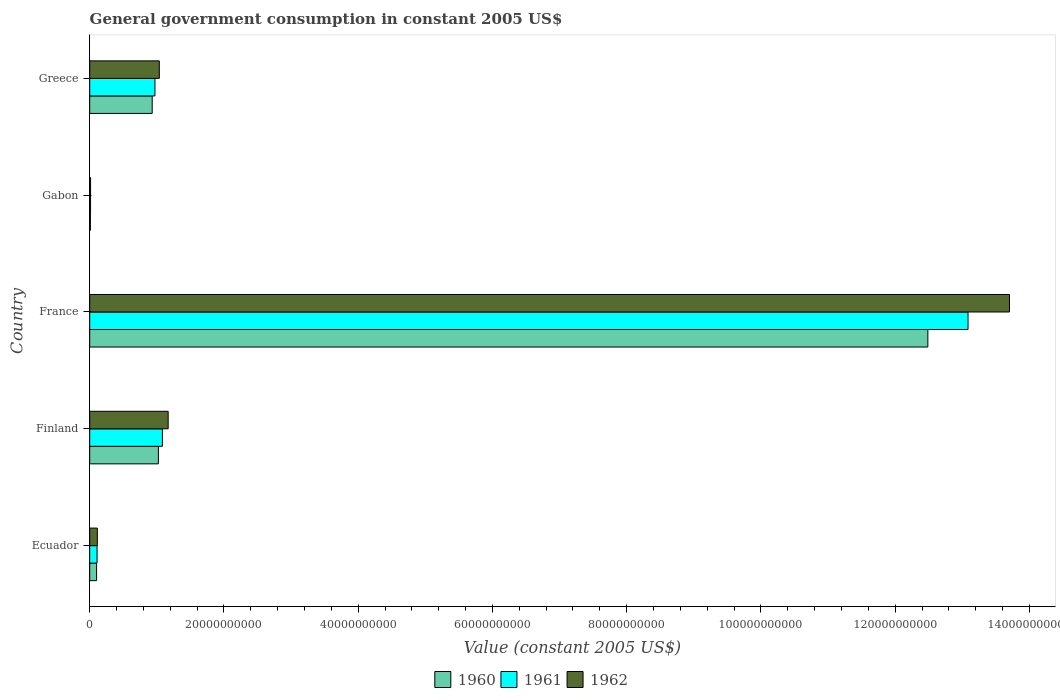How many different coloured bars are there?
Your answer should be very brief. 3. How many groups of bars are there?
Make the answer very short. 5. Are the number of bars per tick equal to the number of legend labels?
Provide a succinct answer. Yes. Are the number of bars on each tick of the Y-axis equal?
Your answer should be compact. Yes. How many bars are there on the 5th tick from the bottom?
Offer a very short reply. 3. What is the label of the 2nd group of bars from the top?
Provide a short and direct response. Gabon. In how many cases, is the number of bars for a given country not equal to the number of legend labels?
Make the answer very short. 0. What is the government conusmption in 1962 in Gabon?
Your answer should be compact. 1.31e+08. Across all countries, what is the maximum government conusmption in 1962?
Provide a short and direct response. 1.37e+11. Across all countries, what is the minimum government conusmption in 1960?
Provide a succinct answer. 1.04e+08. In which country was the government conusmption in 1961 minimum?
Provide a succinct answer. Gabon. What is the total government conusmption in 1961 in the graph?
Give a very brief answer. 1.53e+11. What is the difference between the government conusmption in 1960 in Ecuador and that in Greece?
Provide a short and direct response. -8.29e+09. What is the difference between the government conusmption in 1962 in Greece and the government conusmption in 1961 in France?
Make the answer very short. -1.20e+11. What is the average government conusmption in 1961 per country?
Provide a succinct answer. 3.05e+1. What is the difference between the government conusmption in 1961 and government conusmption in 1960 in Finland?
Provide a succinct answer. 5.98e+08. In how many countries, is the government conusmption in 1961 greater than 84000000000 US$?
Keep it short and to the point. 1. What is the ratio of the government conusmption in 1961 in Finland to that in France?
Provide a succinct answer. 0.08. What is the difference between the highest and the second highest government conusmption in 1960?
Ensure brevity in your answer.  1.15e+11. What is the difference between the highest and the lowest government conusmption in 1961?
Ensure brevity in your answer.  1.31e+11. In how many countries, is the government conusmption in 1960 greater than the average government conusmption in 1960 taken over all countries?
Ensure brevity in your answer.  1. Is the sum of the government conusmption in 1962 in Ecuador and Greece greater than the maximum government conusmption in 1960 across all countries?
Provide a succinct answer. No. Is it the case that in every country, the sum of the government conusmption in 1960 and government conusmption in 1961 is greater than the government conusmption in 1962?
Your answer should be very brief. Yes. How many bars are there?
Provide a short and direct response. 15. Are all the bars in the graph horizontal?
Make the answer very short. Yes. Does the graph contain any zero values?
Keep it short and to the point. No. Where does the legend appear in the graph?
Offer a very short reply. Bottom center. How are the legend labels stacked?
Provide a short and direct response. Horizontal. What is the title of the graph?
Provide a succinct answer. General government consumption in constant 2005 US$. Does "2004" appear as one of the legend labels in the graph?
Ensure brevity in your answer.  No. What is the label or title of the X-axis?
Provide a succinct answer. Value (constant 2005 US$). What is the label or title of the Y-axis?
Your answer should be compact. Country. What is the Value (constant 2005 US$) in 1960 in Ecuador?
Your answer should be compact. 1.03e+09. What is the Value (constant 2005 US$) of 1961 in Ecuador?
Offer a very short reply. 1.10e+09. What is the Value (constant 2005 US$) of 1962 in Ecuador?
Your answer should be very brief. 1.14e+09. What is the Value (constant 2005 US$) in 1960 in Finland?
Provide a short and direct response. 1.02e+1. What is the Value (constant 2005 US$) in 1961 in Finland?
Provide a short and direct response. 1.08e+1. What is the Value (constant 2005 US$) in 1962 in Finland?
Offer a terse response. 1.17e+1. What is the Value (constant 2005 US$) of 1960 in France?
Ensure brevity in your answer.  1.25e+11. What is the Value (constant 2005 US$) in 1961 in France?
Your answer should be compact. 1.31e+11. What is the Value (constant 2005 US$) of 1962 in France?
Keep it short and to the point. 1.37e+11. What is the Value (constant 2005 US$) in 1960 in Gabon?
Offer a terse response. 1.04e+08. What is the Value (constant 2005 US$) of 1961 in Gabon?
Ensure brevity in your answer.  1.27e+08. What is the Value (constant 2005 US$) of 1962 in Gabon?
Keep it short and to the point. 1.31e+08. What is the Value (constant 2005 US$) of 1960 in Greece?
Your answer should be very brief. 9.31e+09. What is the Value (constant 2005 US$) of 1961 in Greece?
Provide a succinct answer. 9.72e+09. What is the Value (constant 2005 US$) in 1962 in Greece?
Give a very brief answer. 1.04e+1. Across all countries, what is the maximum Value (constant 2005 US$) in 1960?
Your answer should be very brief. 1.25e+11. Across all countries, what is the maximum Value (constant 2005 US$) in 1961?
Offer a very short reply. 1.31e+11. Across all countries, what is the maximum Value (constant 2005 US$) in 1962?
Provide a succinct answer. 1.37e+11. Across all countries, what is the minimum Value (constant 2005 US$) in 1960?
Ensure brevity in your answer.  1.04e+08. Across all countries, what is the minimum Value (constant 2005 US$) of 1961?
Your answer should be very brief. 1.27e+08. Across all countries, what is the minimum Value (constant 2005 US$) in 1962?
Offer a terse response. 1.31e+08. What is the total Value (constant 2005 US$) in 1960 in the graph?
Your response must be concise. 1.46e+11. What is the total Value (constant 2005 US$) of 1961 in the graph?
Your answer should be compact. 1.53e+11. What is the total Value (constant 2005 US$) in 1962 in the graph?
Ensure brevity in your answer.  1.60e+11. What is the difference between the Value (constant 2005 US$) of 1960 in Ecuador and that in Finland?
Provide a succinct answer. -9.21e+09. What is the difference between the Value (constant 2005 US$) of 1961 in Ecuador and that in Finland?
Make the answer very short. -9.73e+09. What is the difference between the Value (constant 2005 US$) in 1962 in Ecuador and that in Finland?
Keep it short and to the point. -1.06e+1. What is the difference between the Value (constant 2005 US$) of 1960 in Ecuador and that in France?
Provide a short and direct response. -1.24e+11. What is the difference between the Value (constant 2005 US$) of 1961 in Ecuador and that in France?
Your response must be concise. -1.30e+11. What is the difference between the Value (constant 2005 US$) of 1962 in Ecuador and that in France?
Give a very brief answer. -1.36e+11. What is the difference between the Value (constant 2005 US$) of 1960 in Ecuador and that in Gabon?
Make the answer very short. 9.22e+08. What is the difference between the Value (constant 2005 US$) of 1961 in Ecuador and that in Gabon?
Your answer should be very brief. 9.73e+08. What is the difference between the Value (constant 2005 US$) in 1962 in Ecuador and that in Gabon?
Provide a succinct answer. 1.01e+09. What is the difference between the Value (constant 2005 US$) in 1960 in Ecuador and that in Greece?
Keep it short and to the point. -8.29e+09. What is the difference between the Value (constant 2005 US$) in 1961 in Ecuador and that in Greece?
Your answer should be very brief. -8.62e+09. What is the difference between the Value (constant 2005 US$) of 1962 in Ecuador and that in Greece?
Make the answer very short. -9.23e+09. What is the difference between the Value (constant 2005 US$) of 1960 in Finland and that in France?
Your answer should be compact. -1.15e+11. What is the difference between the Value (constant 2005 US$) in 1961 in Finland and that in France?
Ensure brevity in your answer.  -1.20e+11. What is the difference between the Value (constant 2005 US$) of 1962 in Finland and that in France?
Provide a succinct answer. -1.25e+11. What is the difference between the Value (constant 2005 US$) in 1960 in Finland and that in Gabon?
Your response must be concise. 1.01e+1. What is the difference between the Value (constant 2005 US$) in 1961 in Finland and that in Gabon?
Make the answer very short. 1.07e+1. What is the difference between the Value (constant 2005 US$) of 1962 in Finland and that in Gabon?
Make the answer very short. 1.16e+1. What is the difference between the Value (constant 2005 US$) of 1960 in Finland and that in Greece?
Provide a succinct answer. 9.21e+08. What is the difference between the Value (constant 2005 US$) in 1961 in Finland and that in Greece?
Provide a short and direct response. 1.11e+09. What is the difference between the Value (constant 2005 US$) in 1962 in Finland and that in Greece?
Provide a succinct answer. 1.32e+09. What is the difference between the Value (constant 2005 US$) in 1960 in France and that in Gabon?
Keep it short and to the point. 1.25e+11. What is the difference between the Value (constant 2005 US$) in 1961 in France and that in Gabon?
Your answer should be compact. 1.31e+11. What is the difference between the Value (constant 2005 US$) in 1962 in France and that in Gabon?
Keep it short and to the point. 1.37e+11. What is the difference between the Value (constant 2005 US$) in 1960 in France and that in Greece?
Offer a terse response. 1.16e+11. What is the difference between the Value (constant 2005 US$) of 1961 in France and that in Greece?
Your response must be concise. 1.21e+11. What is the difference between the Value (constant 2005 US$) in 1962 in France and that in Greece?
Ensure brevity in your answer.  1.27e+11. What is the difference between the Value (constant 2005 US$) of 1960 in Gabon and that in Greece?
Your answer should be very brief. -9.21e+09. What is the difference between the Value (constant 2005 US$) of 1961 in Gabon and that in Greece?
Offer a very short reply. -9.60e+09. What is the difference between the Value (constant 2005 US$) in 1962 in Gabon and that in Greece?
Your response must be concise. -1.02e+1. What is the difference between the Value (constant 2005 US$) of 1960 in Ecuador and the Value (constant 2005 US$) of 1961 in Finland?
Keep it short and to the point. -9.81e+09. What is the difference between the Value (constant 2005 US$) of 1960 in Ecuador and the Value (constant 2005 US$) of 1962 in Finland?
Keep it short and to the point. -1.07e+1. What is the difference between the Value (constant 2005 US$) in 1961 in Ecuador and the Value (constant 2005 US$) in 1962 in Finland?
Your response must be concise. -1.06e+1. What is the difference between the Value (constant 2005 US$) of 1960 in Ecuador and the Value (constant 2005 US$) of 1961 in France?
Your answer should be compact. -1.30e+11. What is the difference between the Value (constant 2005 US$) of 1960 in Ecuador and the Value (constant 2005 US$) of 1962 in France?
Keep it short and to the point. -1.36e+11. What is the difference between the Value (constant 2005 US$) in 1961 in Ecuador and the Value (constant 2005 US$) in 1962 in France?
Keep it short and to the point. -1.36e+11. What is the difference between the Value (constant 2005 US$) in 1960 in Ecuador and the Value (constant 2005 US$) in 1961 in Gabon?
Your response must be concise. 8.99e+08. What is the difference between the Value (constant 2005 US$) of 1960 in Ecuador and the Value (constant 2005 US$) of 1962 in Gabon?
Your response must be concise. 8.94e+08. What is the difference between the Value (constant 2005 US$) in 1961 in Ecuador and the Value (constant 2005 US$) in 1962 in Gabon?
Your answer should be very brief. 9.68e+08. What is the difference between the Value (constant 2005 US$) in 1960 in Ecuador and the Value (constant 2005 US$) in 1961 in Greece?
Your response must be concise. -8.70e+09. What is the difference between the Value (constant 2005 US$) in 1960 in Ecuador and the Value (constant 2005 US$) in 1962 in Greece?
Offer a terse response. -9.35e+09. What is the difference between the Value (constant 2005 US$) in 1961 in Ecuador and the Value (constant 2005 US$) in 1962 in Greece?
Provide a short and direct response. -9.27e+09. What is the difference between the Value (constant 2005 US$) of 1960 in Finland and the Value (constant 2005 US$) of 1961 in France?
Make the answer very short. -1.21e+11. What is the difference between the Value (constant 2005 US$) of 1960 in Finland and the Value (constant 2005 US$) of 1962 in France?
Give a very brief answer. -1.27e+11. What is the difference between the Value (constant 2005 US$) in 1961 in Finland and the Value (constant 2005 US$) in 1962 in France?
Provide a succinct answer. -1.26e+11. What is the difference between the Value (constant 2005 US$) in 1960 in Finland and the Value (constant 2005 US$) in 1961 in Gabon?
Offer a very short reply. 1.01e+1. What is the difference between the Value (constant 2005 US$) of 1960 in Finland and the Value (constant 2005 US$) of 1962 in Gabon?
Your answer should be compact. 1.01e+1. What is the difference between the Value (constant 2005 US$) of 1961 in Finland and the Value (constant 2005 US$) of 1962 in Gabon?
Provide a short and direct response. 1.07e+1. What is the difference between the Value (constant 2005 US$) in 1960 in Finland and the Value (constant 2005 US$) in 1961 in Greece?
Ensure brevity in your answer.  5.11e+08. What is the difference between the Value (constant 2005 US$) of 1960 in Finland and the Value (constant 2005 US$) of 1962 in Greece?
Ensure brevity in your answer.  -1.37e+08. What is the difference between the Value (constant 2005 US$) of 1961 in Finland and the Value (constant 2005 US$) of 1962 in Greece?
Provide a short and direct response. 4.61e+08. What is the difference between the Value (constant 2005 US$) in 1960 in France and the Value (constant 2005 US$) in 1961 in Gabon?
Offer a terse response. 1.25e+11. What is the difference between the Value (constant 2005 US$) in 1960 in France and the Value (constant 2005 US$) in 1962 in Gabon?
Give a very brief answer. 1.25e+11. What is the difference between the Value (constant 2005 US$) in 1961 in France and the Value (constant 2005 US$) in 1962 in Gabon?
Keep it short and to the point. 1.31e+11. What is the difference between the Value (constant 2005 US$) of 1960 in France and the Value (constant 2005 US$) of 1961 in Greece?
Your answer should be compact. 1.15e+11. What is the difference between the Value (constant 2005 US$) in 1960 in France and the Value (constant 2005 US$) in 1962 in Greece?
Offer a very short reply. 1.15e+11. What is the difference between the Value (constant 2005 US$) in 1961 in France and the Value (constant 2005 US$) in 1962 in Greece?
Provide a short and direct response. 1.20e+11. What is the difference between the Value (constant 2005 US$) in 1960 in Gabon and the Value (constant 2005 US$) in 1961 in Greece?
Ensure brevity in your answer.  -9.62e+09. What is the difference between the Value (constant 2005 US$) in 1960 in Gabon and the Value (constant 2005 US$) in 1962 in Greece?
Provide a succinct answer. -1.03e+1. What is the difference between the Value (constant 2005 US$) in 1961 in Gabon and the Value (constant 2005 US$) in 1962 in Greece?
Your response must be concise. -1.02e+1. What is the average Value (constant 2005 US$) in 1960 per country?
Your answer should be compact. 2.91e+1. What is the average Value (constant 2005 US$) in 1961 per country?
Offer a terse response. 3.05e+1. What is the average Value (constant 2005 US$) of 1962 per country?
Provide a short and direct response. 3.21e+1. What is the difference between the Value (constant 2005 US$) in 1960 and Value (constant 2005 US$) in 1961 in Ecuador?
Provide a short and direct response. -7.35e+07. What is the difference between the Value (constant 2005 US$) in 1960 and Value (constant 2005 US$) in 1962 in Ecuador?
Your answer should be very brief. -1.12e+08. What is the difference between the Value (constant 2005 US$) of 1961 and Value (constant 2005 US$) of 1962 in Ecuador?
Make the answer very short. -3.85e+07. What is the difference between the Value (constant 2005 US$) of 1960 and Value (constant 2005 US$) of 1961 in Finland?
Your response must be concise. -5.98e+08. What is the difference between the Value (constant 2005 US$) of 1960 and Value (constant 2005 US$) of 1962 in Finland?
Offer a terse response. -1.46e+09. What is the difference between the Value (constant 2005 US$) in 1961 and Value (constant 2005 US$) in 1962 in Finland?
Give a very brief answer. -8.59e+08. What is the difference between the Value (constant 2005 US$) of 1960 and Value (constant 2005 US$) of 1961 in France?
Ensure brevity in your answer.  -5.99e+09. What is the difference between the Value (constant 2005 US$) of 1960 and Value (constant 2005 US$) of 1962 in France?
Ensure brevity in your answer.  -1.22e+1. What is the difference between the Value (constant 2005 US$) in 1961 and Value (constant 2005 US$) in 1962 in France?
Keep it short and to the point. -6.18e+09. What is the difference between the Value (constant 2005 US$) in 1960 and Value (constant 2005 US$) in 1961 in Gabon?
Offer a very short reply. -2.27e+07. What is the difference between the Value (constant 2005 US$) in 1960 and Value (constant 2005 US$) in 1962 in Gabon?
Provide a succinct answer. -2.76e+07. What is the difference between the Value (constant 2005 US$) of 1961 and Value (constant 2005 US$) of 1962 in Gabon?
Offer a terse response. -4.87e+06. What is the difference between the Value (constant 2005 US$) of 1960 and Value (constant 2005 US$) of 1961 in Greece?
Your response must be concise. -4.10e+08. What is the difference between the Value (constant 2005 US$) in 1960 and Value (constant 2005 US$) in 1962 in Greece?
Offer a very short reply. -1.06e+09. What is the difference between the Value (constant 2005 US$) of 1961 and Value (constant 2005 US$) of 1962 in Greece?
Make the answer very short. -6.49e+08. What is the ratio of the Value (constant 2005 US$) in 1960 in Ecuador to that in Finland?
Your answer should be very brief. 0.1. What is the ratio of the Value (constant 2005 US$) in 1961 in Ecuador to that in Finland?
Your answer should be compact. 0.1. What is the ratio of the Value (constant 2005 US$) of 1962 in Ecuador to that in Finland?
Offer a terse response. 0.1. What is the ratio of the Value (constant 2005 US$) of 1960 in Ecuador to that in France?
Offer a terse response. 0.01. What is the ratio of the Value (constant 2005 US$) of 1961 in Ecuador to that in France?
Your answer should be very brief. 0.01. What is the ratio of the Value (constant 2005 US$) in 1962 in Ecuador to that in France?
Provide a succinct answer. 0.01. What is the ratio of the Value (constant 2005 US$) in 1960 in Ecuador to that in Gabon?
Offer a terse response. 9.87. What is the ratio of the Value (constant 2005 US$) of 1961 in Ecuador to that in Gabon?
Provide a short and direct response. 8.68. What is the ratio of the Value (constant 2005 US$) of 1962 in Ecuador to that in Gabon?
Offer a very short reply. 8.65. What is the ratio of the Value (constant 2005 US$) of 1960 in Ecuador to that in Greece?
Offer a very short reply. 0.11. What is the ratio of the Value (constant 2005 US$) of 1961 in Ecuador to that in Greece?
Make the answer very short. 0.11. What is the ratio of the Value (constant 2005 US$) of 1962 in Ecuador to that in Greece?
Ensure brevity in your answer.  0.11. What is the ratio of the Value (constant 2005 US$) in 1960 in Finland to that in France?
Provide a succinct answer. 0.08. What is the ratio of the Value (constant 2005 US$) in 1961 in Finland to that in France?
Ensure brevity in your answer.  0.08. What is the ratio of the Value (constant 2005 US$) in 1962 in Finland to that in France?
Give a very brief answer. 0.09. What is the ratio of the Value (constant 2005 US$) in 1960 in Finland to that in Gabon?
Provide a succinct answer. 98.5. What is the ratio of the Value (constant 2005 US$) of 1961 in Finland to that in Gabon?
Your answer should be very brief. 85.55. What is the ratio of the Value (constant 2005 US$) in 1962 in Finland to that in Gabon?
Your answer should be very brief. 88.91. What is the ratio of the Value (constant 2005 US$) of 1960 in Finland to that in Greece?
Give a very brief answer. 1.1. What is the ratio of the Value (constant 2005 US$) of 1961 in Finland to that in Greece?
Keep it short and to the point. 1.11. What is the ratio of the Value (constant 2005 US$) in 1962 in Finland to that in Greece?
Make the answer very short. 1.13. What is the ratio of the Value (constant 2005 US$) of 1960 in France to that in Gabon?
Offer a terse response. 1201.88. What is the ratio of the Value (constant 2005 US$) in 1961 in France to that in Gabon?
Provide a succinct answer. 1033.44. What is the ratio of the Value (constant 2005 US$) of 1962 in France to that in Gabon?
Offer a very short reply. 1042.14. What is the ratio of the Value (constant 2005 US$) of 1960 in France to that in Greece?
Your response must be concise. 13.41. What is the ratio of the Value (constant 2005 US$) of 1961 in France to that in Greece?
Provide a succinct answer. 13.46. What is the ratio of the Value (constant 2005 US$) of 1962 in France to that in Greece?
Your answer should be compact. 13.21. What is the ratio of the Value (constant 2005 US$) of 1960 in Gabon to that in Greece?
Offer a very short reply. 0.01. What is the ratio of the Value (constant 2005 US$) in 1961 in Gabon to that in Greece?
Ensure brevity in your answer.  0.01. What is the ratio of the Value (constant 2005 US$) in 1962 in Gabon to that in Greece?
Give a very brief answer. 0.01. What is the difference between the highest and the second highest Value (constant 2005 US$) of 1960?
Your answer should be very brief. 1.15e+11. What is the difference between the highest and the second highest Value (constant 2005 US$) of 1961?
Your response must be concise. 1.20e+11. What is the difference between the highest and the second highest Value (constant 2005 US$) of 1962?
Make the answer very short. 1.25e+11. What is the difference between the highest and the lowest Value (constant 2005 US$) in 1960?
Make the answer very short. 1.25e+11. What is the difference between the highest and the lowest Value (constant 2005 US$) in 1961?
Make the answer very short. 1.31e+11. What is the difference between the highest and the lowest Value (constant 2005 US$) in 1962?
Your response must be concise. 1.37e+11. 